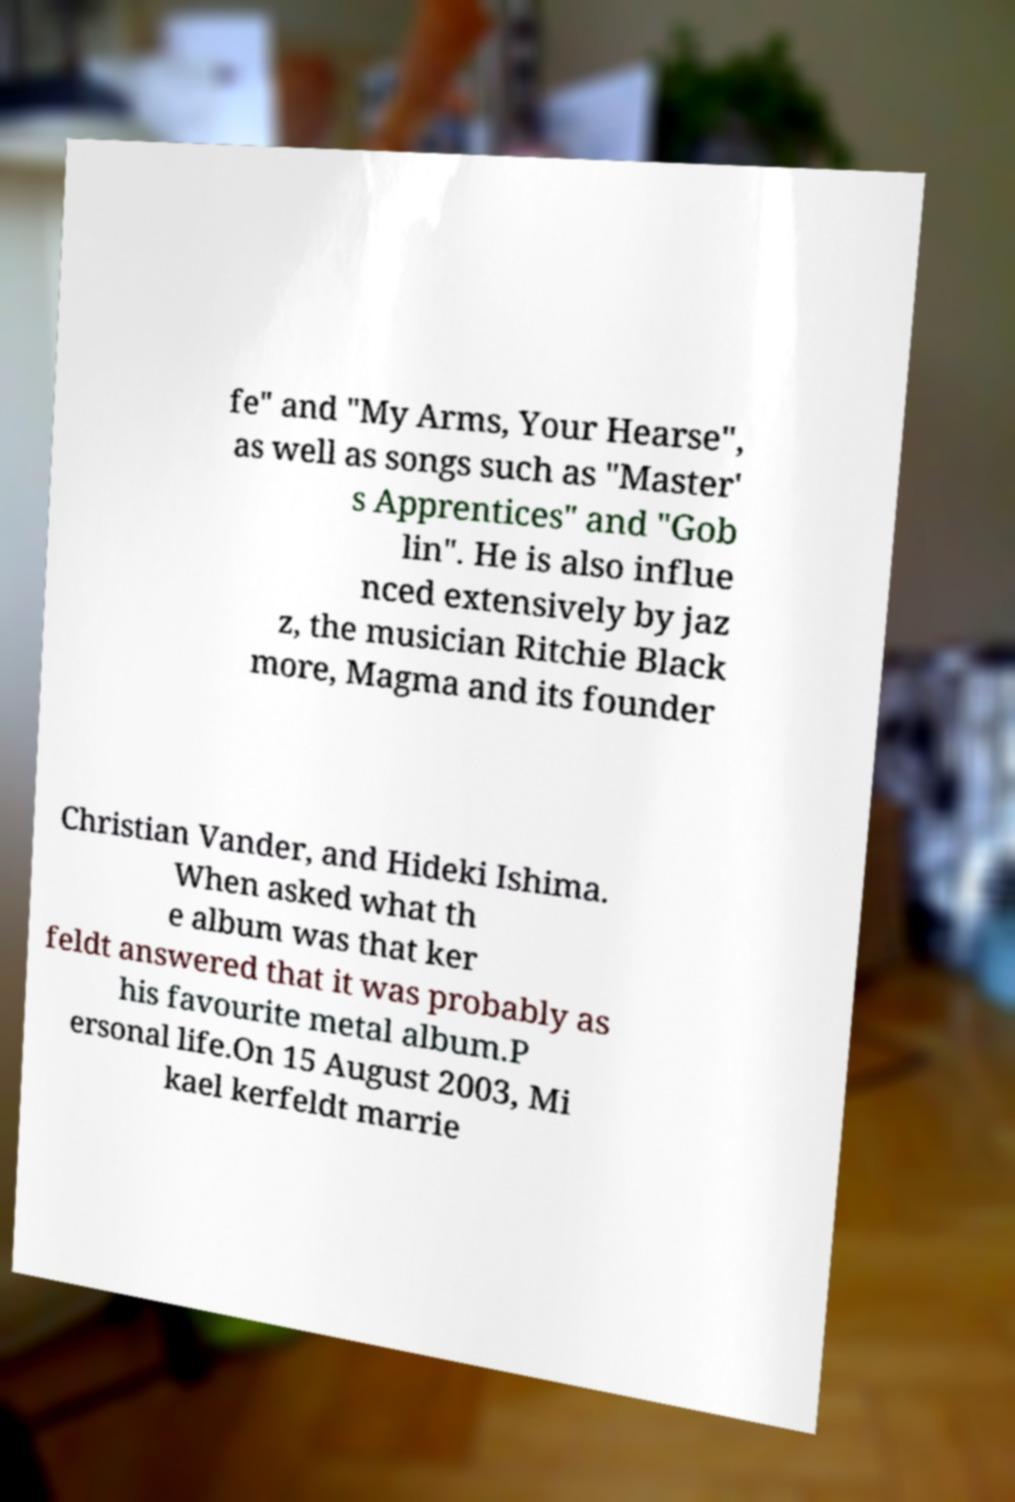Please identify and transcribe the text found in this image. fe" and "My Arms, Your Hearse", as well as songs such as "Master' s Apprentices" and "Gob lin". He is also influe nced extensively by jaz z, the musician Ritchie Black more, Magma and its founder Christian Vander, and Hideki Ishima. When asked what th e album was that ker feldt answered that it was probably as his favourite metal album.P ersonal life.On 15 August 2003, Mi kael kerfeldt marrie 